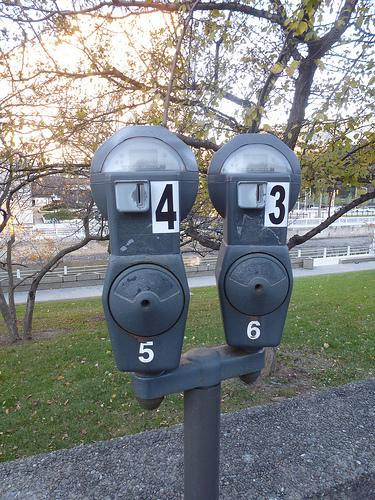Question: how many signals?
Choices:
A. 1.
B. 3.
C. 4.
D. 2.
Answer with the letter. Answer: D Question: what is the color of the signal?
Choices:
A. Brown.
B. Black.
C. Blue.
D. Grey.
Answer with the letter. Answer: D Question: what is the number written?
Choices:
A. 2 and 5.
B. 1 and 6.
C. 7 and 8.
D. 4 and 3.
Answer with the letter. Answer: D Question: how is the day?
Choices:
A. Rainy.
B. Sunny.
C. Humid.
D. Partly Cloudy.
Answer with the letter. Answer: B Question: what is the color of the grass?
Choices:
A. Brown.
B. Grey.
C. Green.
D. Yellow.
Answer with the letter. Answer: C Question: what is the color of the sky?
Choices:
A. White.
B. Grey.
C. Blue and White.
D. Blue.
Answer with the letter. Answer: D Question: where is the picture taken?
Choices:
A. Countryside.
B. Metropolis.
C. Small town.
D. On the street.
Answer with the letter. Answer: D 